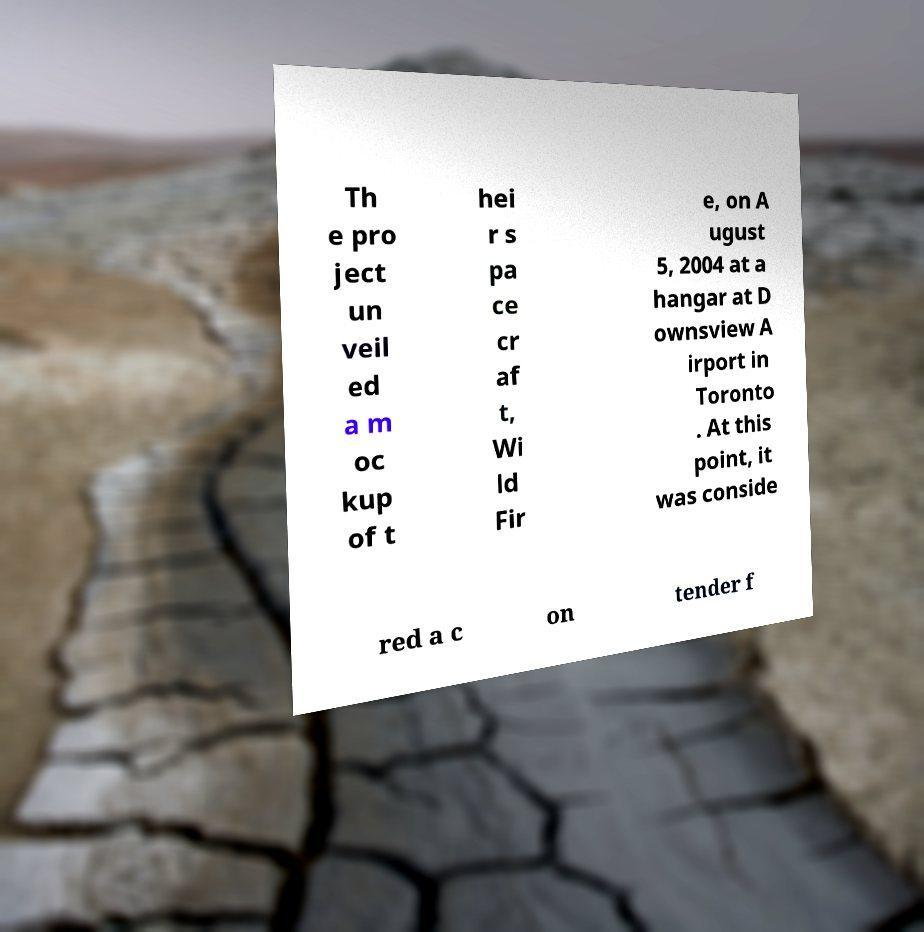Could you assist in decoding the text presented in this image and type it out clearly? Th e pro ject un veil ed a m oc kup of t hei r s pa ce cr af t, Wi ld Fir e, on A ugust 5, 2004 at a hangar at D ownsview A irport in Toronto . At this point, it was conside red a c on tender f 